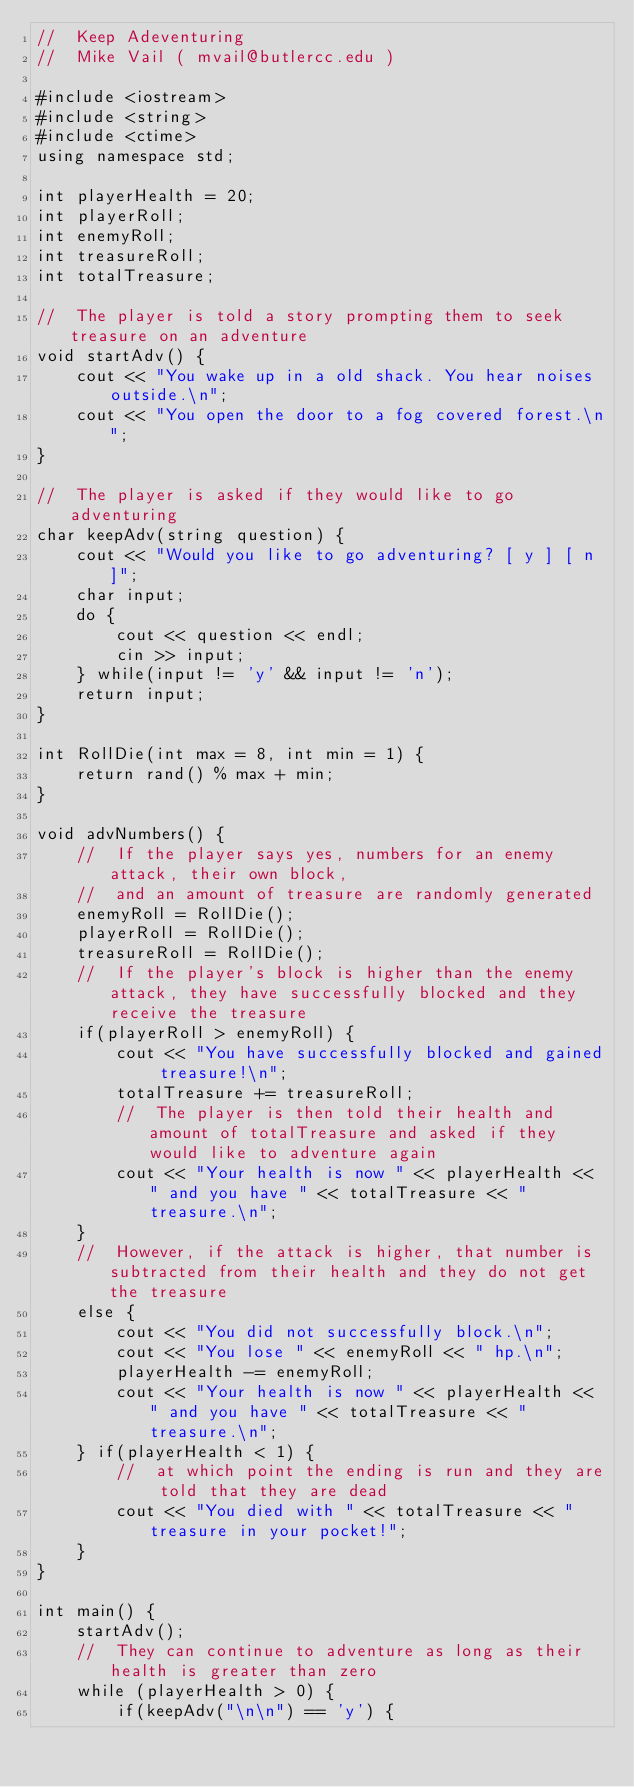Convert code to text. <code><loc_0><loc_0><loc_500><loc_500><_C++_>//  Keep Adeventuring
//  Mike Vail ( mvail@butlercc.edu )

#include <iostream>
#include <string>
#include <ctime>
using namespace std;

int playerHealth = 20;
int playerRoll;
int enemyRoll;
int treasureRoll;
int totalTreasure;

//	The player is told a story prompting them to seek treasure on an adventure
void startAdv() {
    cout << "You wake up in a old shack. You hear noises outside.\n";
	cout << "You open the door to a fog covered forest.\n";
}

//	The player is asked if they would like to go adventuring
char keepAdv(string question) {
	cout << "Would you like to go adventuring? [ y ] [ n ]";
	char input;
	do {
		cout << question << endl;
		cin >> input;
	} while(input != 'y' && input != 'n');
	return input;
}

int RollDie(int max = 8, int min = 1) {
	return rand() % max + min;
}

void advNumbers() {
	//	If the player says yes, numbers for an enemy attack, their own block,
	//	and an amount of treasure are randomly generated
	enemyRoll = RollDie();
	playerRoll = RollDie();
	treasureRoll = RollDie();
	//	If the player's block is higher than the enemy attack, they have successfully blocked and they receive the treasure
	if(playerRoll > enemyRoll) {
		cout << "You have successfully blocked and gained treasure!\n";
		totalTreasure += treasureRoll;
		//	The player is then told their health and amount of totalTreasure and asked if they would like to adventure again
		cout << "Your health is now " << playerHealth << " and you have " << totalTreasure << " treasure.\n";
	}
	//	However, if the attack is higher, that number is subtracted from their health and they do not get the treasure
 	else {
		cout << "You did not successfully block.\n";
		cout << "You lose " << enemyRoll << " hp.\n";
		playerHealth -= enemyRoll;
		cout << "Your health is now " << playerHealth << " and you have " << totalTreasure << " treasure.\n";
	} if(playerHealth < 1) {
		//	at which point the ending is run and they are told that they are dead
		cout << "You died with " << totalTreasure << " treasure in your pocket!";
	}
}

int main() {
    startAdv();
	//	They can continue to adventure as long as their health is greater than zero
	while (playerHealth > 0) {
	    if(keepAdv("\n\n") == 'y') {</code> 